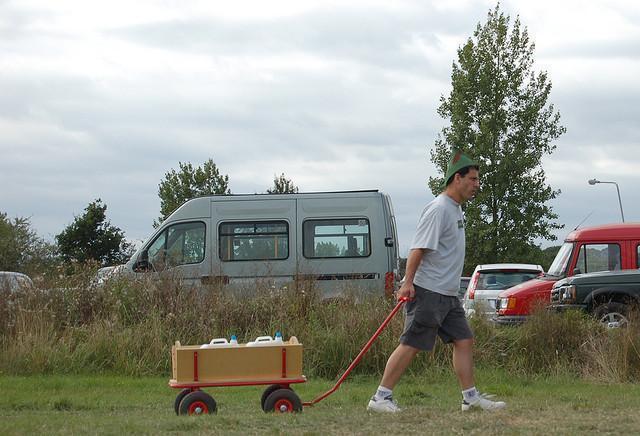What color is the main body of the cart pulled by this guy?
Pick the right solution, then justify: 'Answer: answer
Rationale: rationale.'
Options: Red, orange, wood, blue. Answer: wood.
Rationale: The beige brown color of the cart being pulled identifies it as wood. 